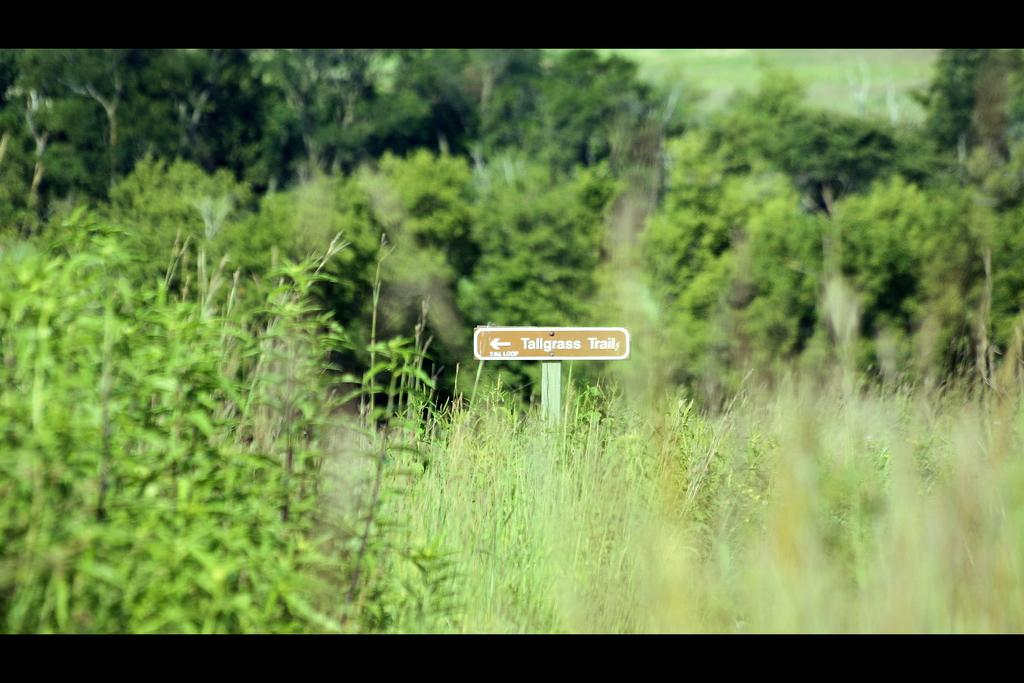What type of vegetation can be seen in the image? There is grass, plants, and trees in the image. What structure is present in the image that provides directions? There is a direction board attached to a pole in the image. What type of mountain can be seen in the image? There is no mountain present in the image. How does the society depicted in the image interact with the plants? There is no society depicted in the image, as it primarily features natural elements such as grass, plants, trees, and a direction board. 